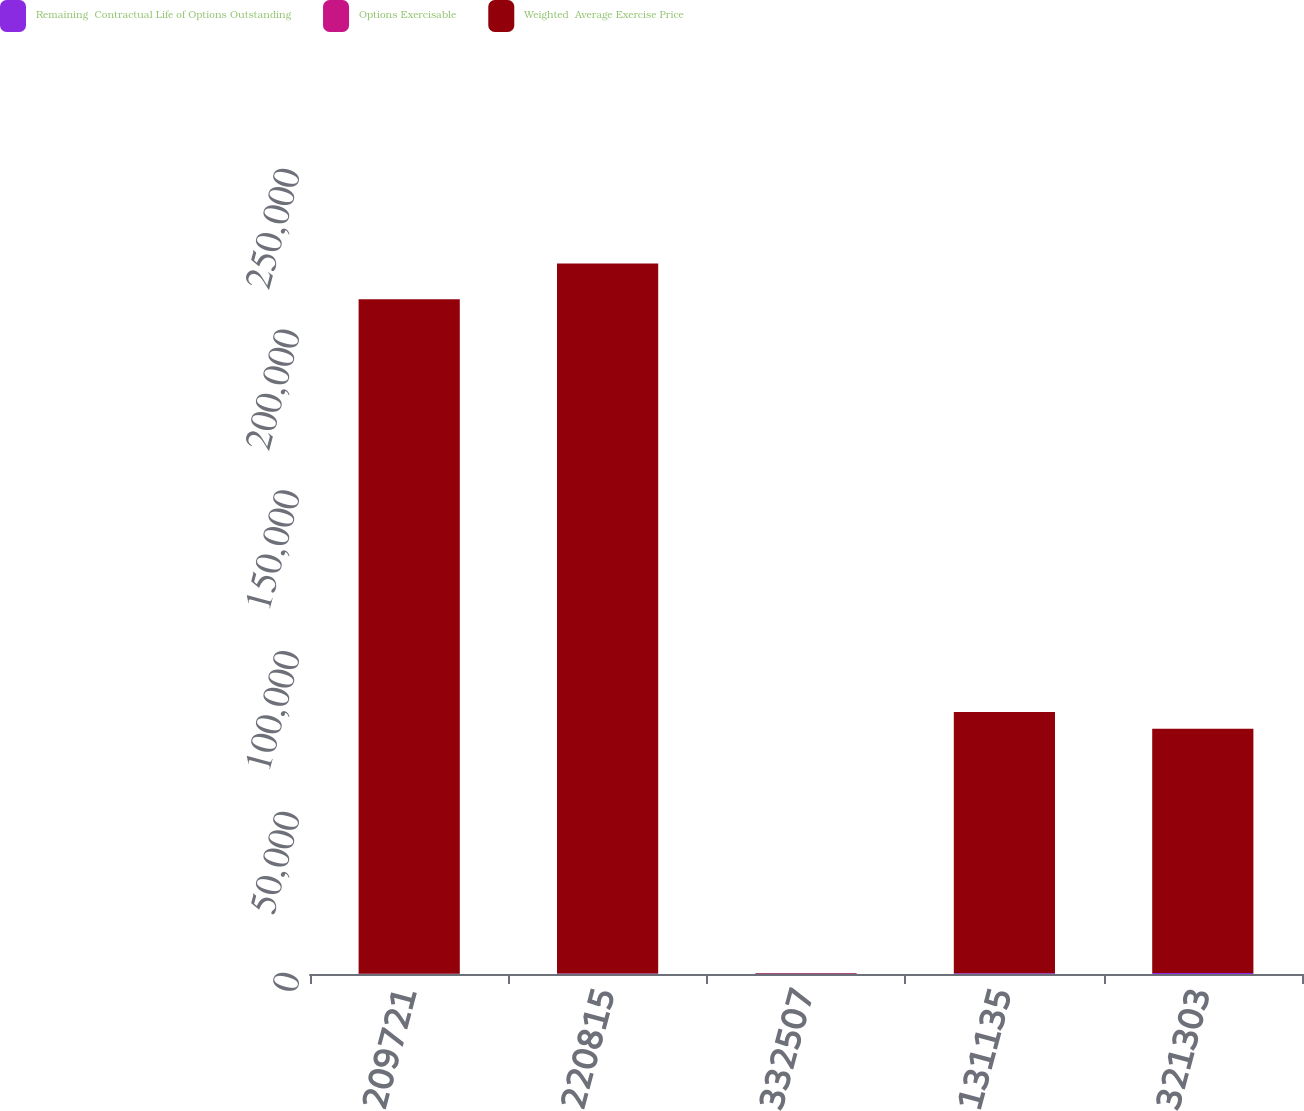<chart> <loc_0><loc_0><loc_500><loc_500><stacked_bar_chart><ecel><fcel>209721<fcel>220815<fcel>332507<fcel>131135<fcel>321303<nl><fcel>Remaining  Contractual Life of Options Outstanding<fcel>87.36<fcel>127.63<fcel>159.62<fcel>244.99<fcel>318.83<nl><fcel>Options Exercisable<fcel>2.6<fcel>3.1<fcel>5.3<fcel>6.8<fcel>8.8<nl><fcel>Weighted  Average Exercise Price<fcel>209721<fcel>220815<fcel>143.625<fcel>81249<fcel>75894<nl></chart> 